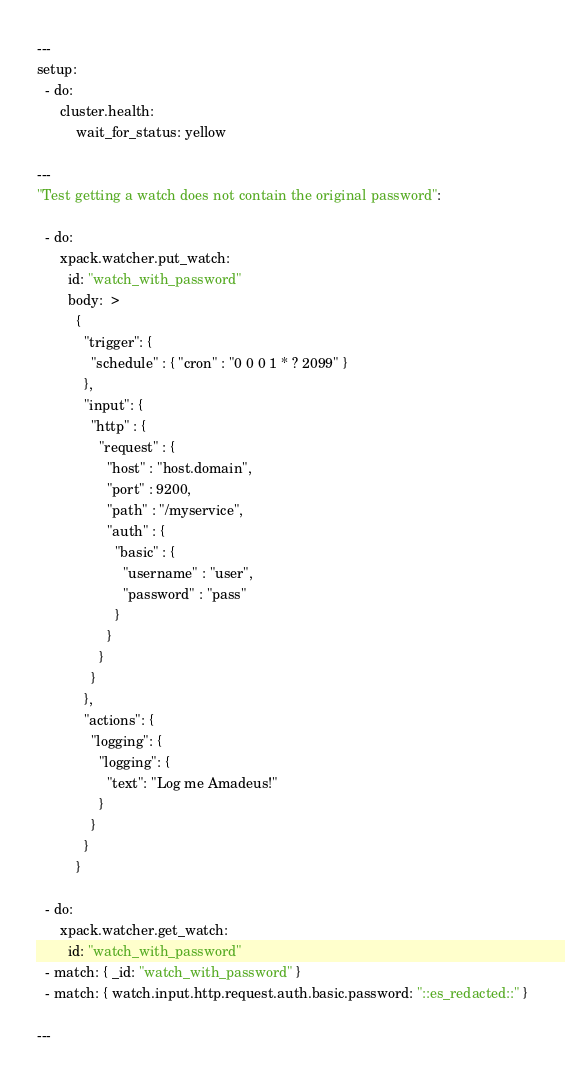Convert code to text. <code><loc_0><loc_0><loc_500><loc_500><_YAML_>---
setup:
  - do:
      cluster.health:
          wait_for_status: yellow

---
"Test getting a watch does not contain the original password":

  - do:
      xpack.watcher.put_watch:
        id: "watch_with_password"
        body:  >
          {
            "trigger": {
              "schedule" : { "cron" : "0 0 0 1 * ? 2099" }
            },
            "input": {
              "http" : {
                "request" : {
                  "host" : "host.domain",
                  "port" : 9200,
                  "path" : "/myservice",
                  "auth" : {
                    "basic" : {
                      "username" : "user",
                      "password" : "pass"
                    }
                  }
                }
              }
            },
            "actions": {
              "logging": {
                "logging": {
                  "text": "Log me Amadeus!"
                }
              }
            }
          }

  - do:
      xpack.watcher.get_watch:
        id: "watch_with_password"
  - match: { _id: "watch_with_password" }
  - match: { watch.input.http.request.auth.basic.password: "::es_redacted::" }

---</code> 